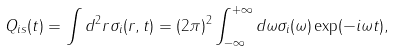<formula> <loc_0><loc_0><loc_500><loc_500>Q _ { i s } ( t ) = \int d ^ { 2 } { r } \sigma _ { i } ( { r } , t ) = ( 2 \pi ) ^ { 2 } \int _ { - \infty } ^ { + \infty } d \omega \sigma _ { i } ( \omega ) \exp ( - i \omega t ) ,</formula> 